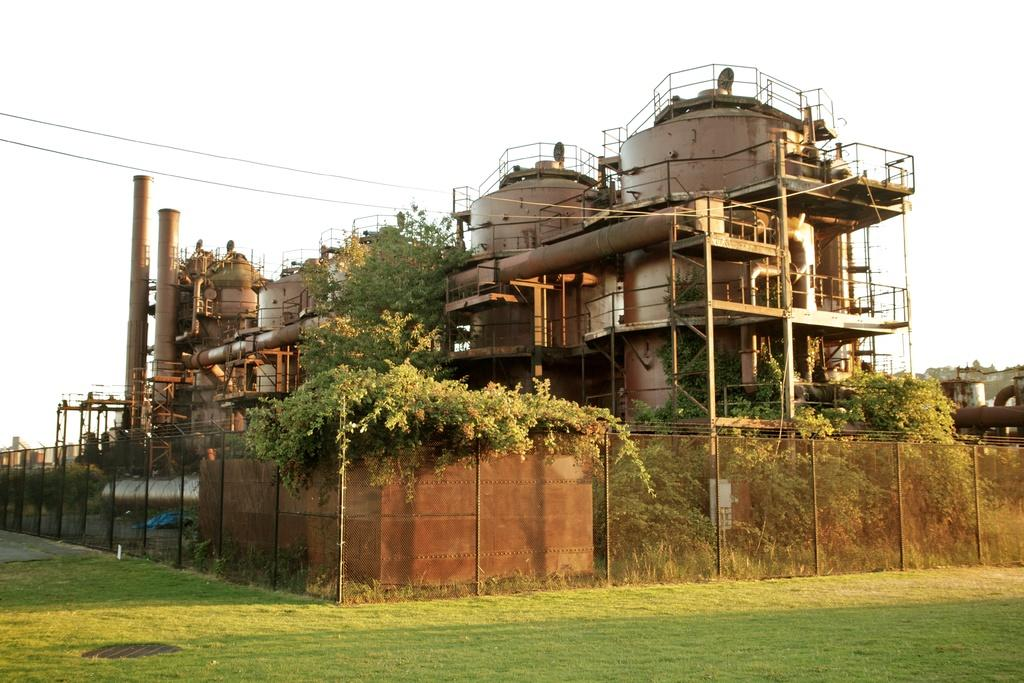What type of location is depicted in the image? The image appears to depict a factory. What specific features can be seen at the factory? There are pipes visible in the image. What type of barrier is present around the factory? There is a fence in the image. What type of vegetation is present near the factory? Trees are present in the image. What type of ground cover is visible at the bottom of the image? Grass is visible at the bottom of the image. What part of the natural environment is visible in the image? The sky is visible in the image. How many police officers are patrolling the factory in the image? There are no police officers visible in the image. What type of clocks are hanging on the walls of the factory in the image? There are no clocks visible in the image. 